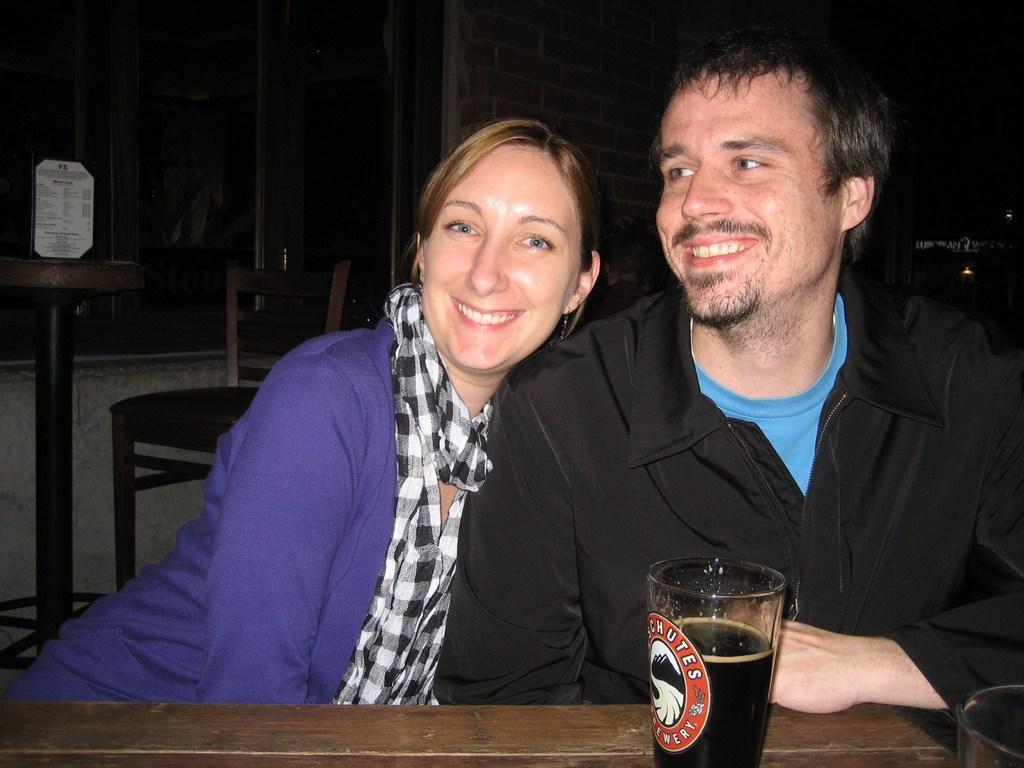Could you give a brief overview of what you see in this image? We can see a man and a woman are sitting on the chairs at the table. There is a glass with liquid in it on a table. On the right at the bottom corner there is a glass. In the background the image is dark but we can see a chair,card on the table,wall,light and other objects. 